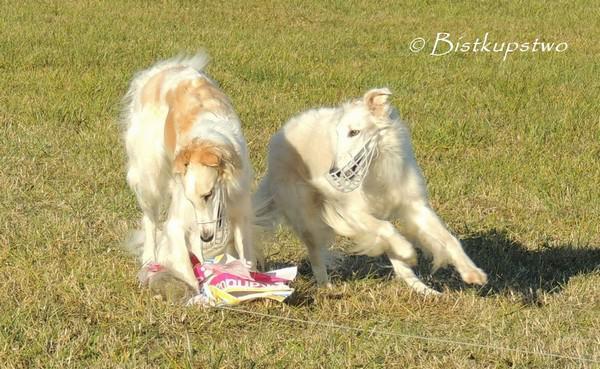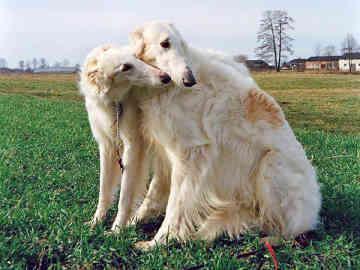The first image is the image on the left, the second image is the image on the right. For the images shown, is this caption "Each image shows exactly two furry hounds posed next to each other outdoors on grass." true? Answer yes or no. Yes. The first image is the image on the left, the second image is the image on the right. Examine the images to the left and right. Is the description "There are two dogs in each image." accurate? Answer yes or no. Yes. 